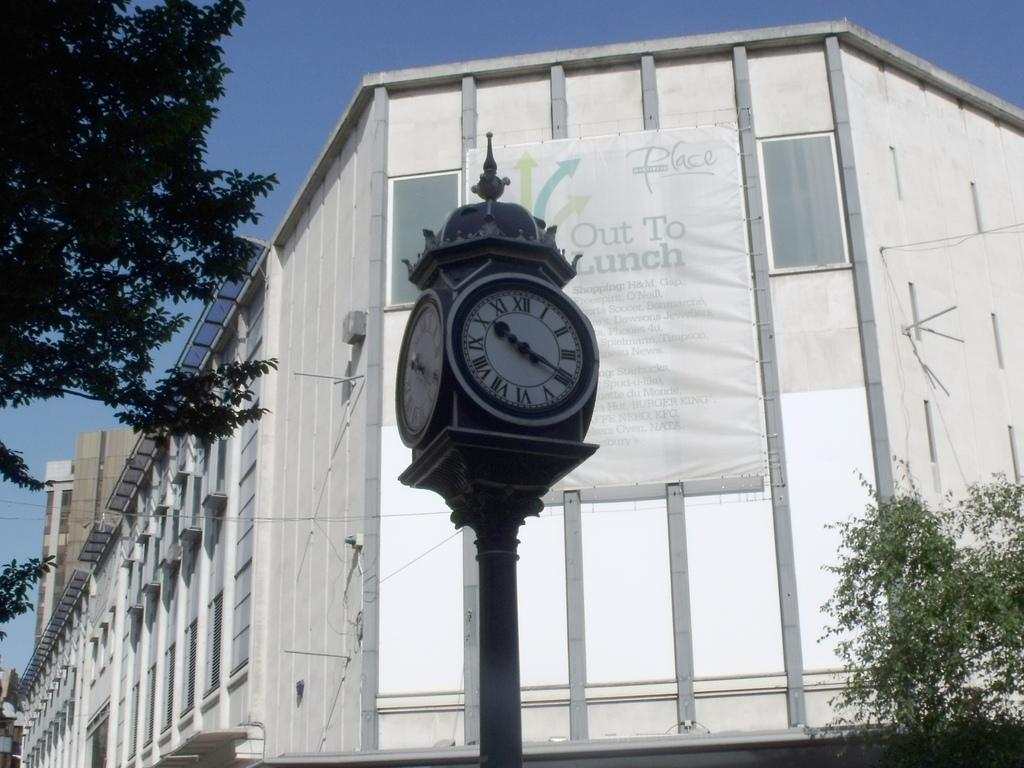<image>
Render a clear and concise summary of the photo. roman numeral clock outside in front of a big building 